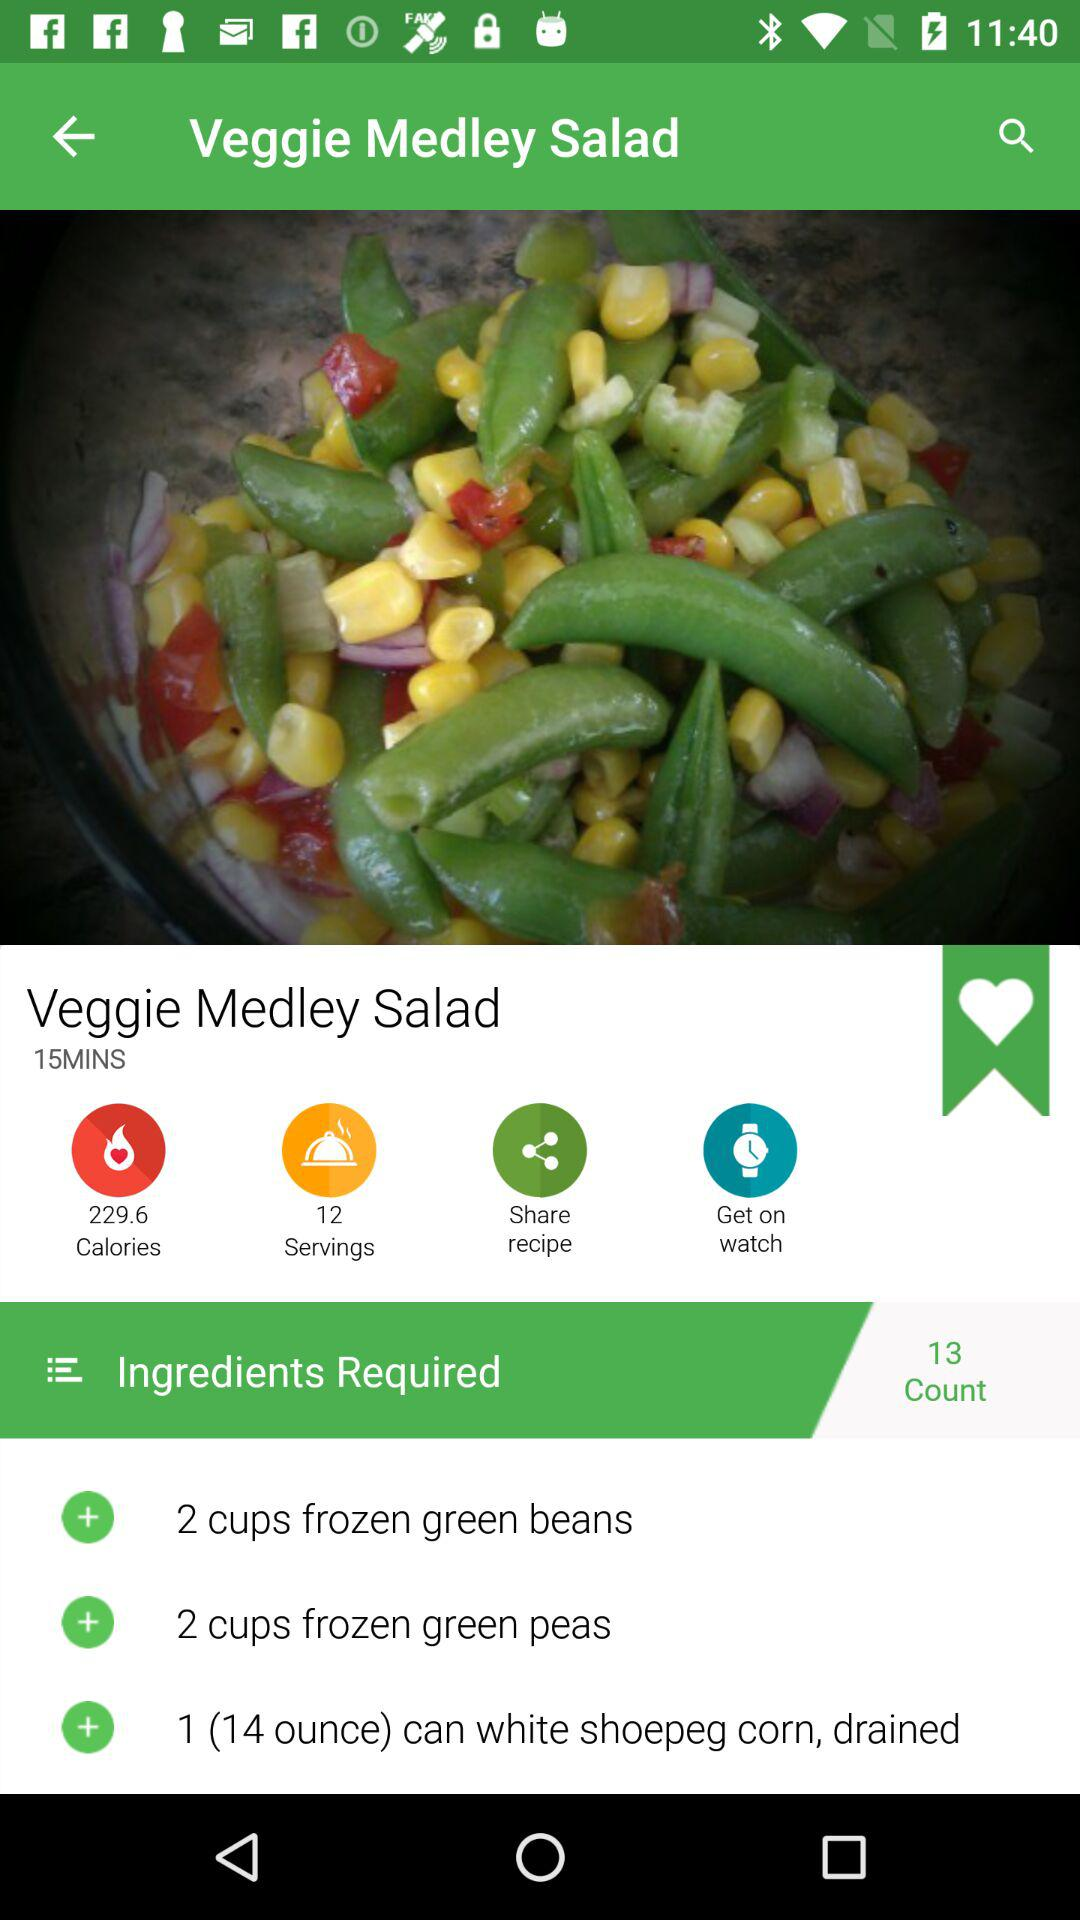How many calories are in this recipe?
Answer the question using a single word or phrase. 229.6 